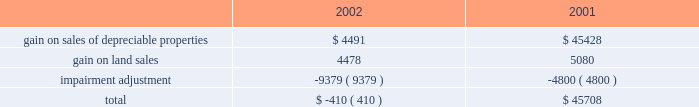Management 2019s discussion and analysis of financial conditionand results of operations d u k e r e a l t y c o r p o r a t i o n 1 1 2 0 0 2 a n n u a l r e p o r t 2022 interest expense on the company 2019s secured debt decreased from $ 30.8 million in 2001 to $ 22.9 million in 2002 as the company paid off $ 13.5 million of secured debt throughout 2002 and experienced lower borrowings on its secured line of credit during 2002 compared to 2001 .
Additionally , the company paid off approximately $ 128.5 million of secured debt throughout 2001 .
2022 interest expense on the company 2019s $ 500 million unsecured line of credit decreased by approximately $ 1.1 million in 2002 compared to 2001 as the company maintained lower balances on the line throughout most of 2002 .
As a result of the above-mentioned items , earnings from rental operations decreased $ 35.0 million from $ 254.1 million for the year ended december 31 , 2001 , to $ 219.1 million for the year ended december 31 , 2002 .
Service operations service operations primarily consist of leasing , management , construction and development services for joint venture properties and properties owned by third parties .
Service operations revenues decreased from $ 80.5 million for the year ended december 31 , 2001 , to $ 68.6 million for the year ended december 31 , 2002 .
The prolonged effect of the slow economy has been the primary factor in the overall decrease in revenues .
The company experienced a decrease of $ 12.7 million in net general contractor revenues because of a decrease in the volume of construction in 2002 , compared to 2001 , as well as slightly lower profit margins .
Property management , maintenance and leasing fee revenues decreased from $ 22.8 million in 2001 to $ 14.3 million in 2002 primarily because of a decrease in landscaping maintenance revenue resulting from the sale of the landscaping operations in the third quarter of 2001 .
Construction management and development activity income represents construction and development fees earned on projects where the company acts as the construction manager along with profits from the company 2019s held for sale program whereby the company develops a property for sale upon completion .
The increase in revenues of $ 10.3 million in 2002 is primarily due to an increase in volume of the sale of properties from the held for sale program .
Service operations expenses decreased from $ 45.3 million in 2001 to $ 38.3 million in 2002 .
The decrease is attributable to the decrease in construction and development activity and the reduced overhead costs as a result of the sale of the landscape business in 2001 .
As a result of the above , earnings from service operations decreased from $ 35.1 million for the year ended december 31 , 2001 , to $ 30.3 million for the year ended december 31 , 2002 .
General and administrative expense general and administrative expense increased from $ 15.6 million in 2001 to $ 25.4 million for the year ended december 31 , 2002 .
The company has been successful reducing total operating and administration costs ; however , reduced construction and development activities have resulted in a greater amount of overhead being charged to general and administrative expense instead of being capitalized into development projects or charged to service operations .
Other income and expenses gain on sale of land and depreciable property dispositions , net of impairment adjustment , is comprised of the following amounts in 2002 and 2001 : gain on sales of depreciable properties represent sales of previously held for investment rental properties .
Beginning in 2000 and continuing into 2001 , the company pursued favorable opportunities to dispose of real estate assets that no longer met long-term investment objectives .
In 2002 , the company significantly reduced this property sales program until the business climate improves and provides better investment opportunities for the sale proceeds .
Gain on land sales represents sales of undeveloped land owned by the company .
The company pursues opportunities to dispose of land in markets with a high concentration of undeveloped land and those markets where the land no longer meets strategic development plans of the company .
The company recorded a $ 9.4 million adjustment in 2002 associated with six properties determined to have an impairment of book value .
The company has analyzed each of its in-service properties and has determined that there are no additional valuation adjustments that need to be made as of december 31 , 2002 .
The company recorded an adjustment of $ 4.8 million in 2001 for one property that the company had contracted to sell for a price less than its book value .
Other revenue for the year ended december 31 , 2002 , includes $ 1.4 million of gain related to an interest rate swap that did not qualify for hedge accounting. .

What was the percentage change in the general and administrative expenses from 2001 to , 2002 .? 
Computations: ((25.4 - 15.6) / 15.6)
Answer: 0.62821. 